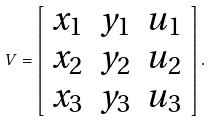<formula> <loc_0><loc_0><loc_500><loc_500>V = \left [ \begin{array} { c c c } x _ { 1 } & y _ { 1 } & u _ { 1 } \\ x _ { 2 } & y _ { 2 } & u _ { 2 } \\ x _ { 3 } & y _ { 3 } & u _ { 3 } \end{array} \right ] .</formula> 